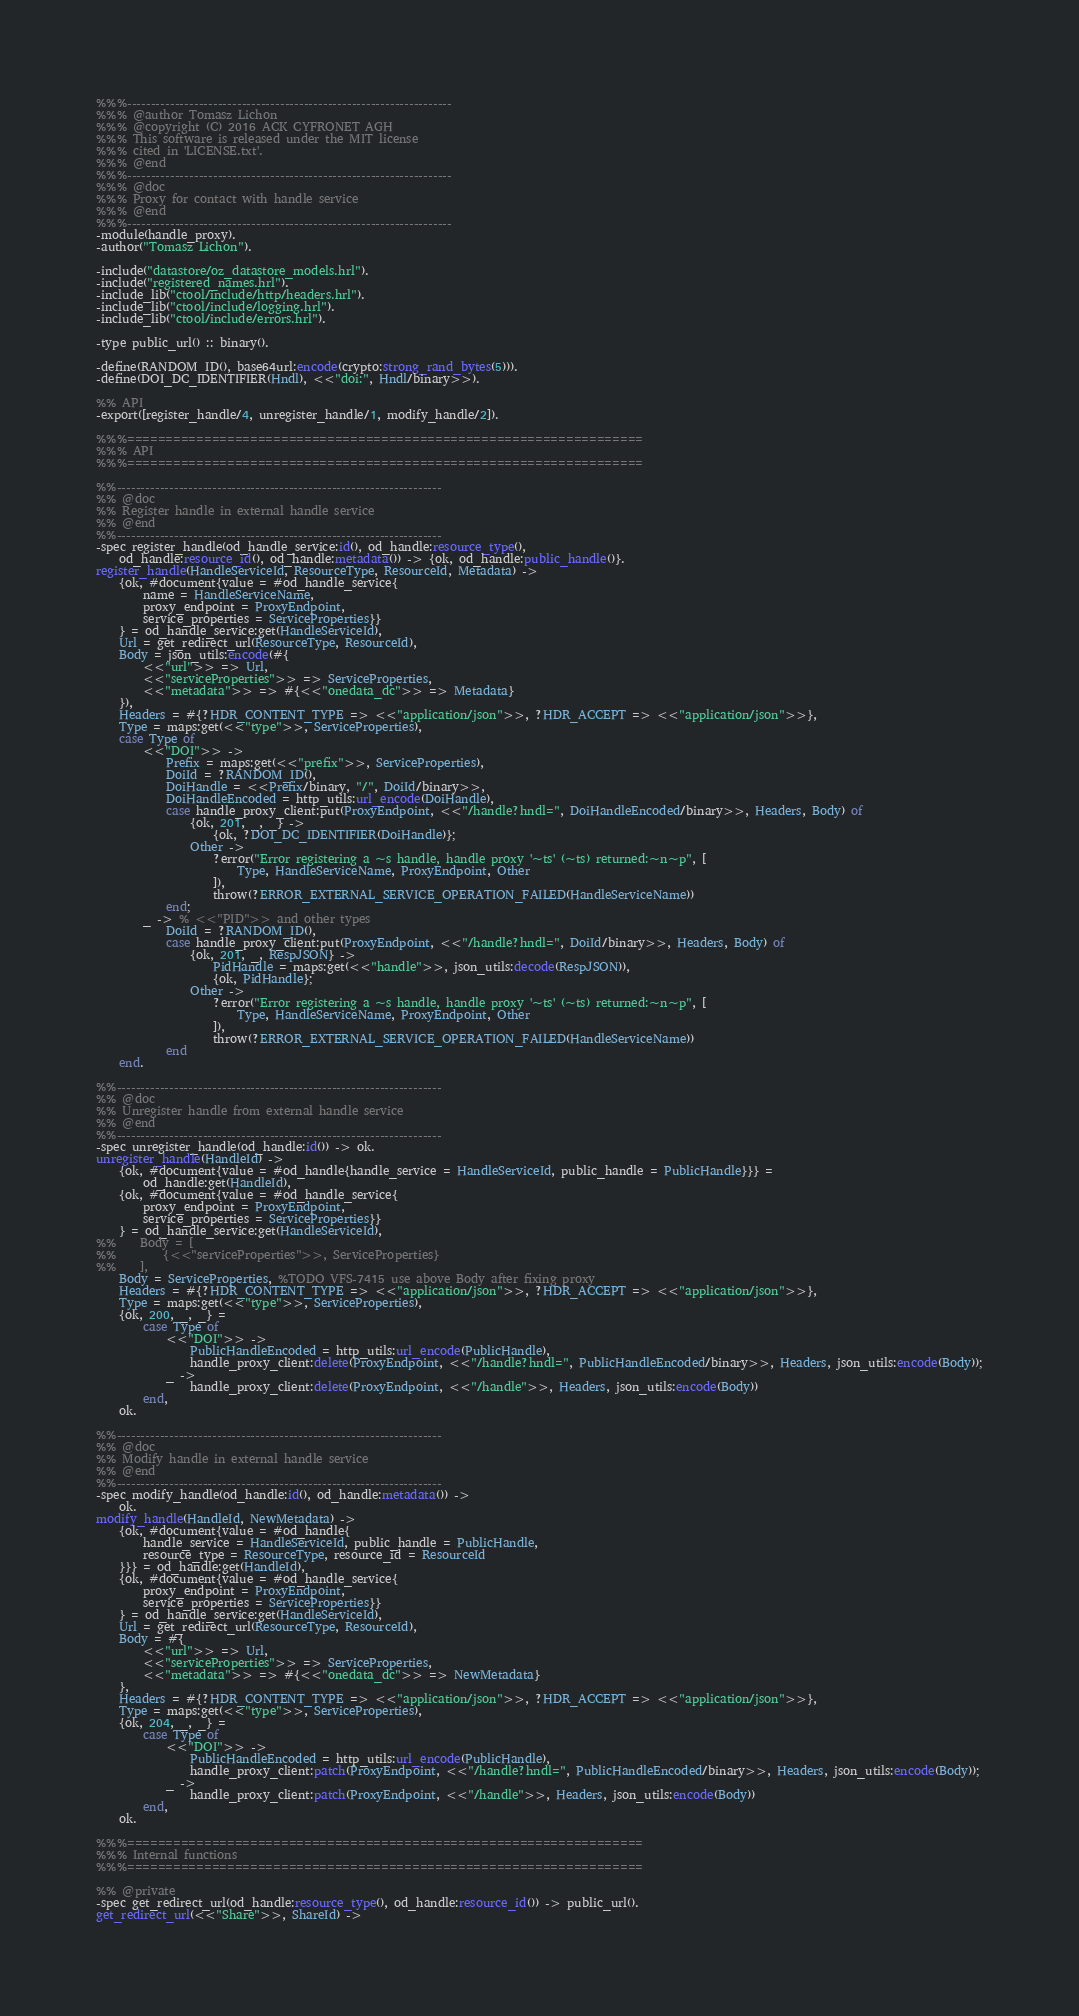<code> <loc_0><loc_0><loc_500><loc_500><_Erlang_>%%%--------------------------------------------------------------------
%%% @author Tomasz Lichon
%%% @copyright (C) 2016 ACK CYFRONET AGH
%%% This software is released under the MIT license
%%% cited in 'LICENSE.txt'.
%%% @end
%%%--------------------------------------------------------------------
%%% @doc
%%% Proxy for contact with handle service
%%% @end
%%%--------------------------------------------------------------------
-module(handle_proxy).
-author("Tomasz Lichon").

-include("datastore/oz_datastore_models.hrl").
-include("registered_names.hrl").
-include_lib("ctool/include/http/headers.hrl").
-include_lib("ctool/include/logging.hrl").
-include_lib("ctool/include/errors.hrl").

-type public_url() :: binary().

-define(RANDOM_ID(), base64url:encode(crypto:strong_rand_bytes(5))).
-define(DOI_DC_IDENTIFIER(Hndl), <<"doi:", Hndl/binary>>).

%% API
-export([register_handle/4, unregister_handle/1, modify_handle/2]).

%%%===================================================================
%%% API
%%%===================================================================

%%--------------------------------------------------------------------
%% @doc
%% Register handle in external handle service
%% @end
%%--------------------------------------------------------------------
-spec register_handle(od_handle_service:id(), od_handle:resource_type(),
    od_handle:resource_id(), od_handle:metadata()) -> {ok, od_handle:public_handle()}.
register_handle(HandleServiceId, ResourceType, ResourceId, Metadata) ->
    {ok, #document{value = #od_handle_service{
        name = HandleServiceName,
        proxy_endpoint = ProxyEndpoint,
        service_properties = ServiceProperties}}
    } = od_handle_service:get(HandleServiceId),
    Url = get_redirect_url(ResourceType, ResourceId),
    Body = json_utils:encode(#{
        <<"url">> => Url,
        <<"serviceProperties">> => ServiceProperties,
        <<"metadata">> => #{<<"onedata_dc">> => Metadata}
    }),
    Headers = #{?HDR_CONTENT_TYPE => <<"application/json">>, ?HDR_ACCEPT => <<"application/json">>},
    Type = maps:get(<<"type">>, ServiceProperties),
    case Type of
        <<"DOI">> ->
            Prefix = maps:get(<<"prefix">>, ServiceProperties),
            DoiId = ?RANDOM_ID(),
            DoiHandle = <<Prefix/binary, "/", DoiId/binary>>,
            DoiHandleEncoded = http_utils:url_encode(DoiHandle),
            case handle_proxy_client:put(ProxyEndpoint, <<"/handle?hndl=", DoiHandleEncoded/binary>>, Headers, Body) of
                {ok, 201, _, _} ->
                    {ok, ?DOI_DC_IDENTIFIER(DoiHandle)};
                Other ->
                    ?error("Error registering a ~s handle, handle proxy '~ts' (~ts) returned:~n~p", [
                        Type, HandleServiceName, ProxyEndpoint, Other
                    ]),
                    throw(?ERROR_EXTERNAL_SERVICE_OPERATION_FAILED(HandleServiceName))
            end;
        _ -> % <<"PID">> and other types
            DoiId = ?RANDOM_ID(),
            case handle_proxy_client:put(ProxyEndpoint, <<"/handle?hndl=", DoiId/binary>>, Headers, Body) of
                {ok, 201, _, RespJSON} ->
                    PidHandle = maps:get(<<"handle">>, json_utils:decode(RespJSON)),
                    {ok, PidHandle};
                Other ->
                    ?error("Error registering a ~s handle, handle proxy '~ts' (~ts) returned:~n~p", [
                        Type, HandleServiceName, ProxyEndpoint, Other
                    ]),
                    throw(?ERROR_EXTERNAL_SERVICE_OPERATION_FAILED(HandleServiceName))
            end
    end.

%%--------------------------------------------------------------------
%% @doc
%% Unregister handle from external handle service
%% @end
%%--------------------------------------------------------------------
-spec unregister_handle(od_handle:id()) -> ok.
unregister_handle(HandleId) ->
    {ok, #document{value = #od_handle{handle_service = HandleServiceId, public_handle = PublicHandle}}} =
        od_handle:get(HandleId),
    {ok, #document{value = #od_handle_service{
        proxy_endpoint = ProxyEndpoint,
        service_properties = ServiceProperties}}
    } = od_handle_service:get(HandleServiceId),
%%    Body = [
%%        {<<"serviceProperties">>, ServiceProperties}
%%    ],
    Body = ServiceProperties, %TODO VFS-7415 use above Body after fixing proxy
    Headers = #{?HDR_CONTENT_TYPE => <<"application/json">>, ?HDR_ACCEPT => <<"application/json">>},
    Type = maps:get(<<"type">>, ServiceProperties),
    {ok, 200, _, _} =
        case Type of
            <<"DOI">> ->
                PublicHandleEncoded = http_utils:url_encode(PublicHandle),
                handle_proxy_client:delete(ProxyEndpoint, <<"/handle?hndl=", PublicHandleEncoded/binary>>, Headers, json_utils:encode(Body));
            _ ->
                handle_proxy_client:delete(ProxyEndpoint, <<"/handle">>, Headers, json_utils:encode(Body))
        end,
    ok.

%%--------------------------------------------------------------------
%% @doc
%% Modify handle in external handle service
%% @end
%%--------------------------------------------------------------------
-spec modify_handle(od_handle:id(), od_handle:metadata()) ->
    ok.
modify_handle(HandleId, NewMetadata) ->
    {ok, #document{value = #od_handle{
        handle_service = HandleServiceId, public_handle = PublicHandle,
        resource_type = ResourceType, resource_id = ResourceId
    }}} = od_handle:get(HandleId),
    {ok, #document{value = #od_handle_service{
        proxy_endpoint = ProxyEndpoint,
        service_properties = ServiceProperties}}
    } = od_handle_service:get(HandleServiceId),
    Url = get_redirect_url(ResourceType, ResourceId),
    Body = #{
        <<"url">> => Url,
        <<"serviceProperties">> => ServiceProperties,
        <<"metadata">> => #{<<"onedata_dc">> => NewMetadata}
    },
    Headers = #{?HDR_CONTENT_TYPE => <<"application/json">>, ?HDR_ACCEPT => <<"application/json">>},
    Type = maps:get(<<"type">>, ServiceProperties),
    {ok, 204, _, _} =
        case Type of
            <<"DOI">> ->
                PublicHandleEncoded = http_utils:url_encode(PublicHandle),
                handle_proxy_client:patch(ProxyEndpoint, <<"/handle?hndl=", PublicHandleEncoded/binary>>, Headers, json_utils:encode(Body));
            _ ->
                handle_proxy_client:patch(ProxyEndpoint, <<"/handle">>, Headers, json_utils:encode(Body))
        end,
    ok.

%%%===================================================================
%%% Internal functions
%%%===================================================================

%% @private
-spec get_redirect_url(od_handle:resource_type(), od_handle:resource_id()) -> public_url().
get_redirect_url(<<"Share">>, ShareId) -></code> 